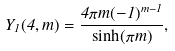<formula> <loc_0><loc_0><loc_500><loc_500>Y _ { 1 } ( 4 , m ) = \frac { 4 \pi m ( - 1 ) ^ { m - 1 } } { \sinh ( \pi m ) } ,</formula> 